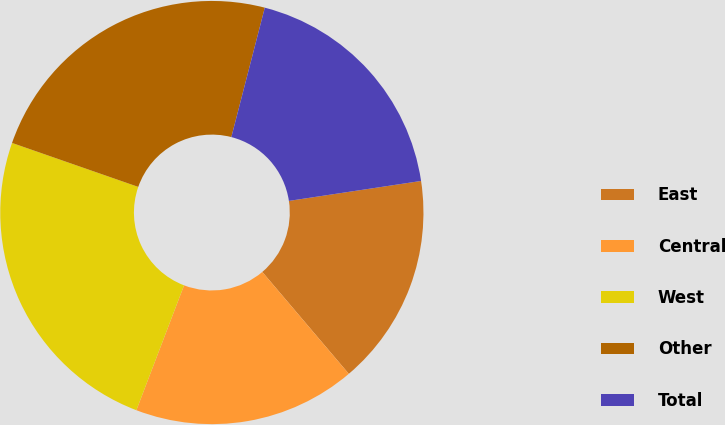Convert chart. <chart><loc_0><loc_0><loc_500><loc_500><pie_chart><fcel>East<fcel>Central<fcel>West<fcel>Other<fcel>Total<nl><fcel>16.18%<fcel>17.01%<fcel>24.53%<fcel>23.69%<fcel>18.59%<nl></chart> 